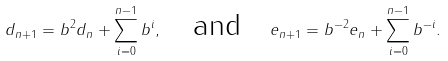<formula> <loc_0><loc_0><loc_500><loc_500>d _ { n + 1 } = b ^ { 2 } d _ { n } + \sum _ { i = 0 } ^ { n - 1 } b ^ { i } , \quad \text {and} \quad e _ { n + 1 } = b ^ { - 2 } e _ { n } + \sum _ { i = 0 } ^ { n - 1 } b ^ { - i } .</formula> 